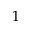Convert formula to latex. <formula><loc_0><loc_0><loc_500><loc_500>1</formula> 